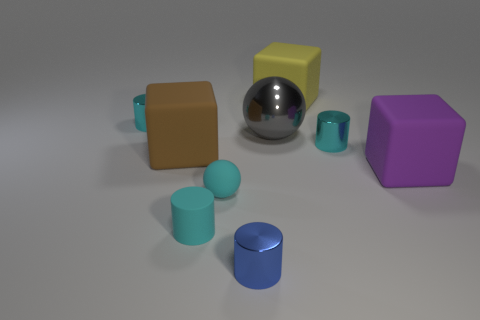There is a brown rubber object that is the same shape as the large yellow matte object; what is its size? The brown rubber object appears to be a cube, similar in shape to the yellow object of the same geometry. Given the relative scale of objects in the image, it would be classified as medium-sized when compared to the other objects present. 